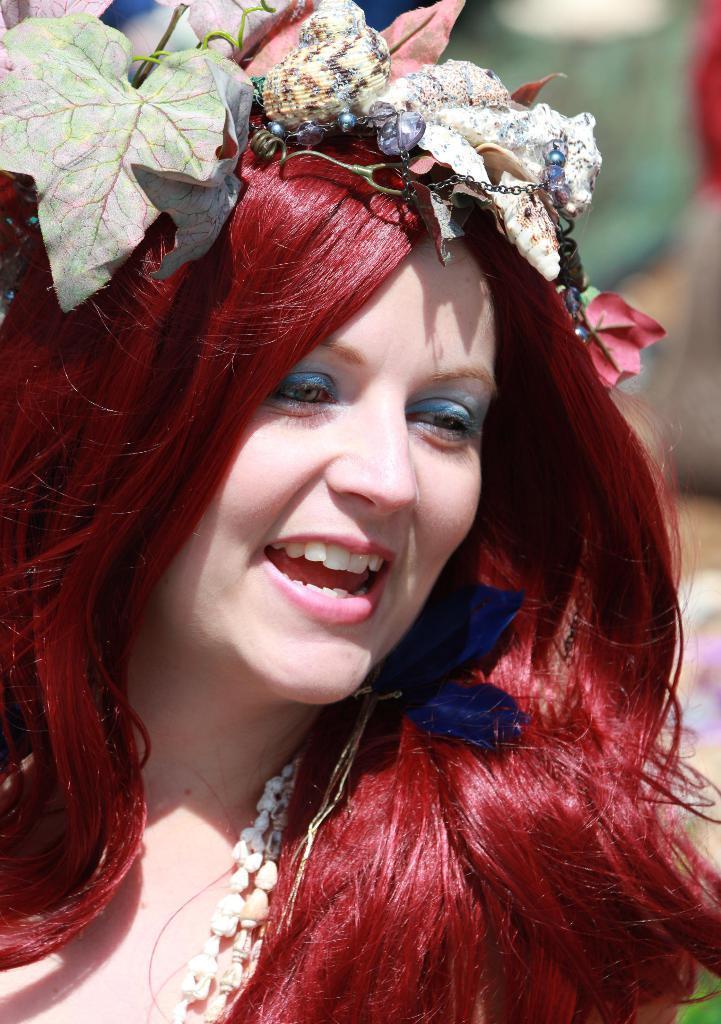In one or two sentences, can you explain what this image depicts? In this picture there is a woman. On her head I can see the leaves and other objects. She is smiling. in the background I can see the blur image. 